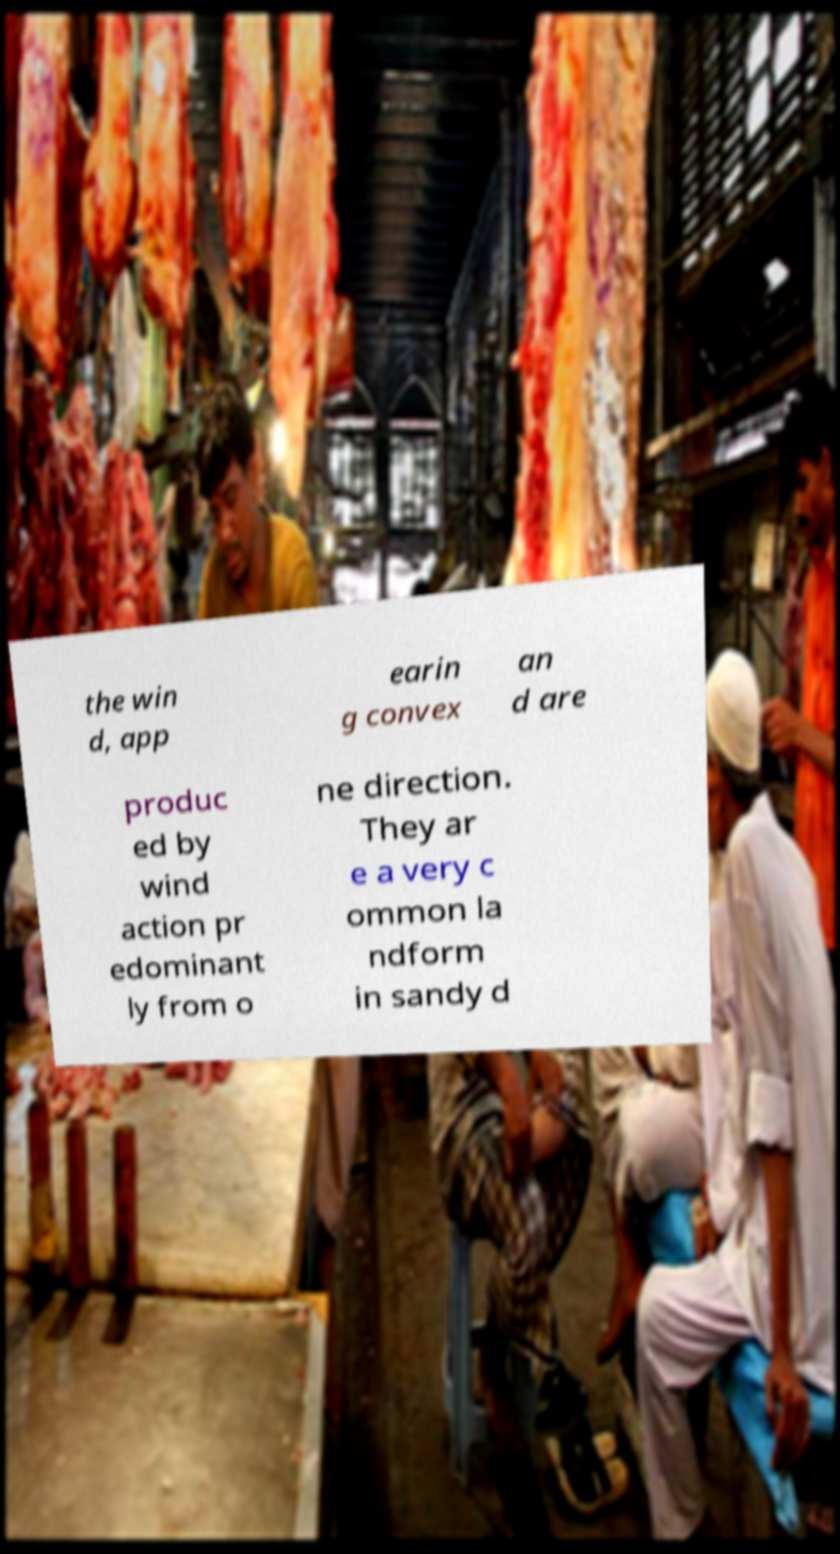Could you extract and type out the text from this image? the win d, app earin g convex an d are produc ed by wind action pr edominant ly from o ne direction. They ar e a very c ommon la ndform in sandy d 